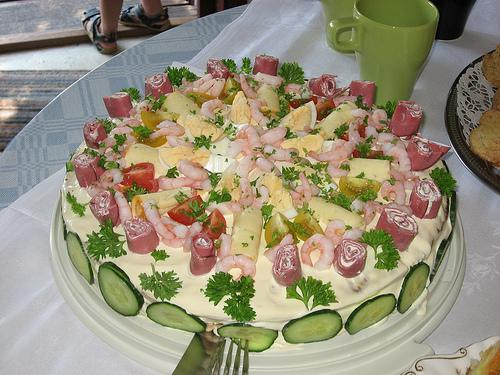Question: what is in the picture?
Choices:
A. A cat.
B. A tree.
C. A plant.
D. Cake.
Answer with the letter. Answer: D Question: what decoration is around the cake?
Choices:
A. Sprinkles.
B. Icing.
C. Ice cream.
D. Cucumber slices.
Answer with the letter. Answer: D Question: who is in the picture's background?
Choices:
A. A child.
B. Mother.
C. Grandmother.
D. Grandfather.
Answer with the letter. Answer: A Question: what seafood is in the photo?
Choices:
A. Octopus.
B. Scallops.
C. Fish.
D. Shrimps.
Answer with the letter. Answer: D 